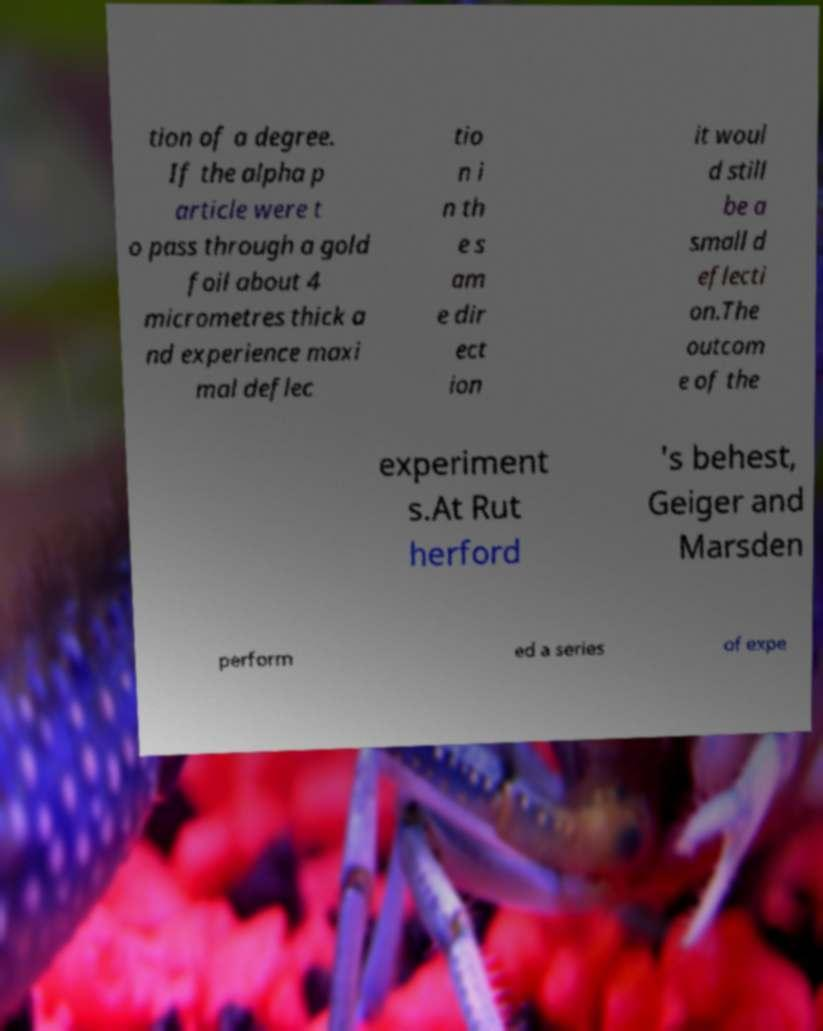Could you assist in decoding the text presented in this image and type it out clearly? tion of a degree. If the alpha p article were t o pass through a gold foil about 4 micrometres thick a nd experience maxi mal deflec tio n i n th e s am e dir ect ion it woul d still be a small d eflecti on.The outcom e of the experiment s.At Rut herford 's behest, Geiger and Marsden perform ed a series of expe 